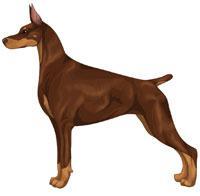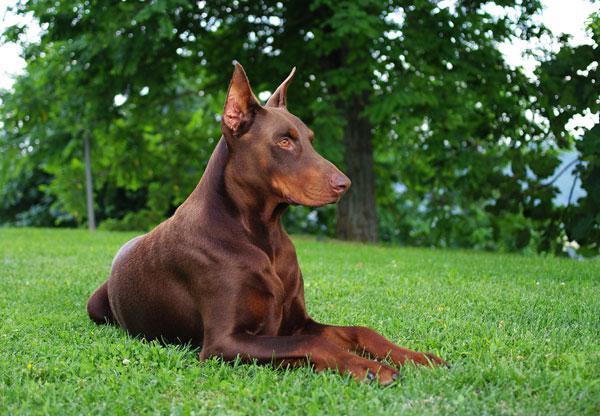The first image is the image on the left, the second image is the image on the right. For the images displayed, is the sentence "A dog is laying down." factually correct? Answer yes or no. Yes. The first image is the image on the left, the second image is the image on the right. For the images displayed, is the sentence "There are only 2 dogs." factually correct? Answer yes or no. Yes. 